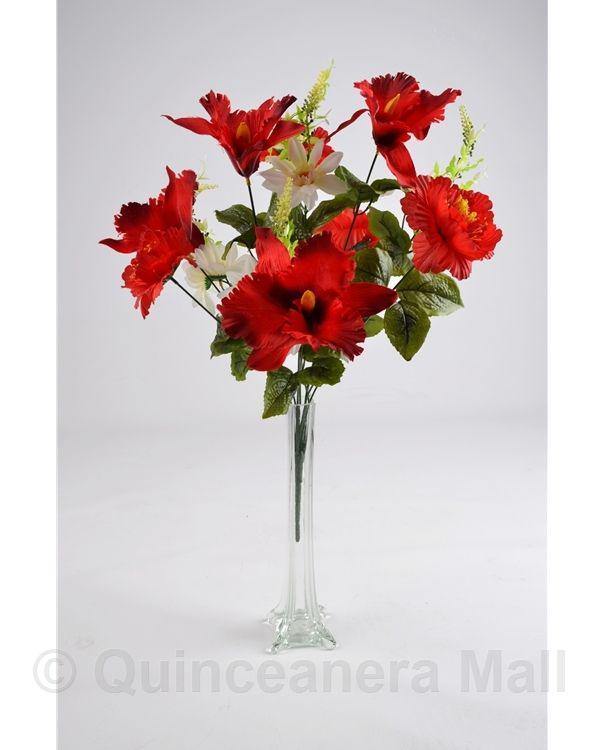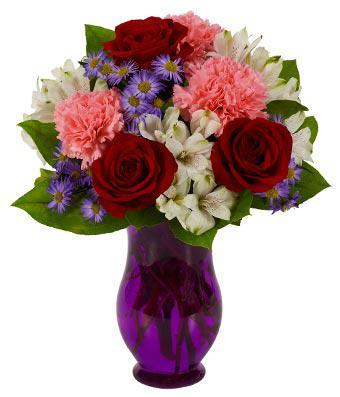The first image is the image on the left, the second image is the image on the right. Analyze the images presented: Is the assertion "One of the vases is purple." valid? Answer yes or no. Yes. 